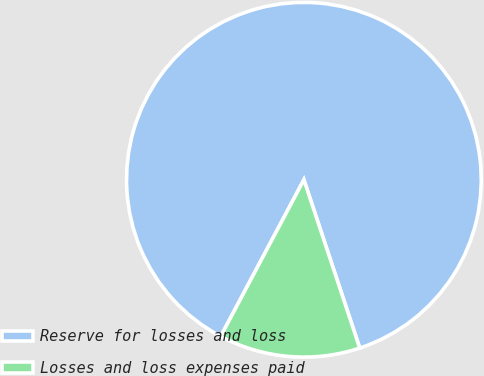Convert chart to OTSL. <chart><loc_0><loc_0><loc_500><loc_500><pie_chart><fcel>Reserve for losses and loss<fcel>Losses and loss expenses paid<nl><fcel>87.13%<fcel>12.87%<nl></chart> 